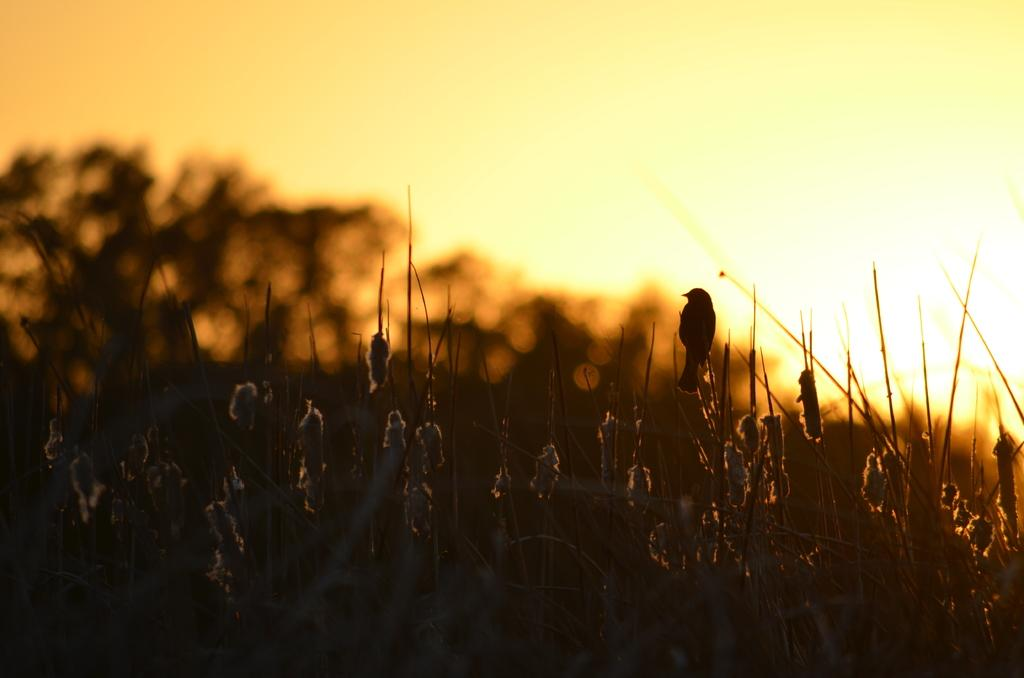What type of animal is on a plant in the image? There is a bird on a plant in the image. What other types of vegetation can be seen in the image? There are plants visible in the image. What material is present in the image? Cotton is present in the image. What can be seen in the background of the image? There are trees in the background of the image. What is visible at the top of the image? The sky is visible at the top of the image. What color is the shirt worn by the bird in the image? There is no bird wearing a shirt in the image; it is a bird on a plant. How does the notebook help the balloon float in the image? There is no notebook or balloon present in the image. 